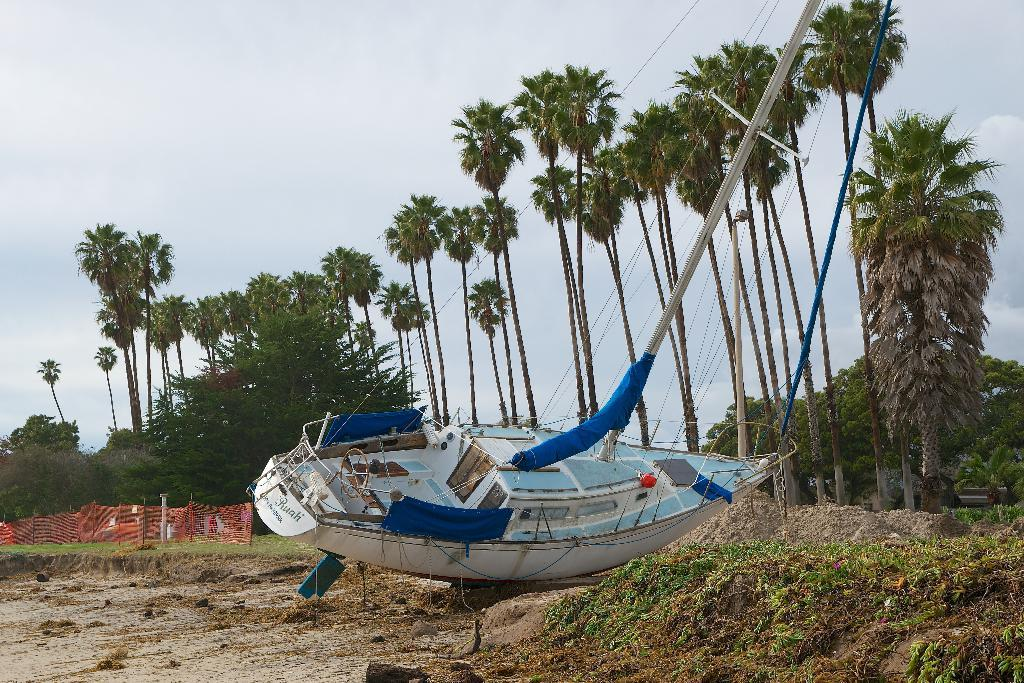What type of boat is in the image? There is a blue and white color boat in the image. What is the condition of the boat in the image? The boat is stuck in the ground. What type of vegetation can be seen in the background of the image? There are coconut trees visible in the background. What is the color of the fencing net in the background? The fencing net in the background is red. How many legs does the boat have in the image? Boats do not have legs; they are floating or resting on the ground. The boat in the image is stuck in the ground, but it does not have legs. 